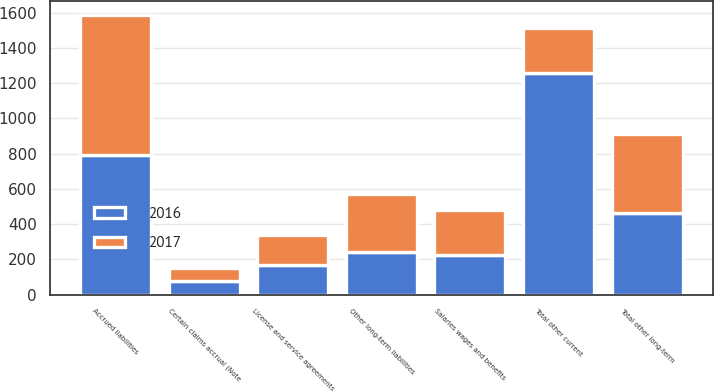<chart> <loc_0><loc_0><loc_500><loc_500><stacked_bar_chart><ecel><fcel>License and service agreements<fcel>Certain claims accrual (Note<fcel>Salaries wages and benefits<fcel>Accrued liabilities<fcel>Total other current<fcel>Other long-term liabilities<fcel>Total other long-term<nl><fcel>2017<fcel>171.4<fcel>78<fcel>255.2<fcel>795.2<fcel>255.2<fcel>324.4<fcel>445.8<nl><fcel>2016<fcel>168<fcel>75<fcel>225.8<fcel>789.1<fcel>1257.9<fcel>244<fcel>462.6<nl></chart> 